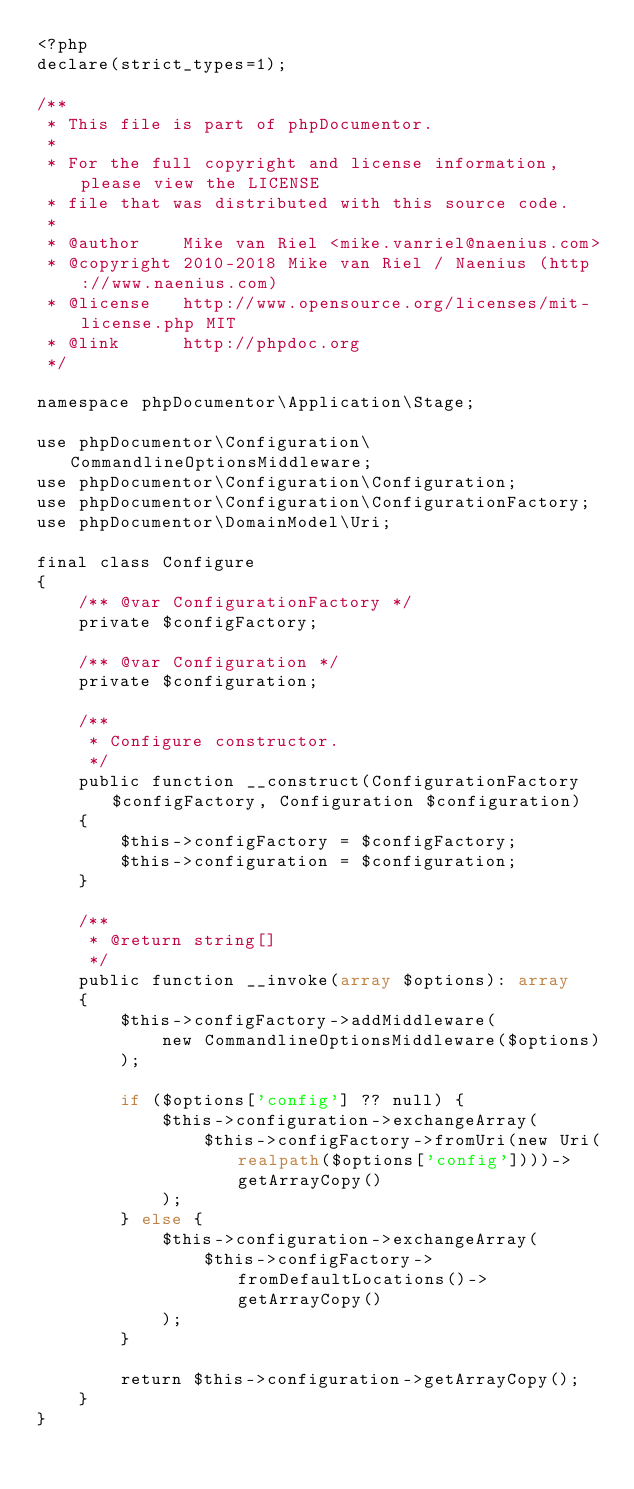<code> <loc_0><loc_0><loc_500><loc_500><_PHP_><?php
declare(strict_types=1);

/**
 * This file is part of phpDocumentor.
 *
 * For the full copyright and license information, please view the LICENSE
 * file that was distributed with this source code.
 *
 * @author    Mike van Riel <mike.vanriel@naenius.com>
 * @copyright 2010-2018 Mike van Riel / Naenius (http://www.naenius.com)
 * @license   http://www.opensource.org/licenses/mit-license.php MIT
 * @link      http://phpdoc.org
 */

namespace phpDocumentor\Application\Stage;

use phpDocumentor\Configuration\CommandlineOptionsMiddleware;
use phpDocumentor\Configuration\Configuration;
use phpDocumentor\Configuration\ConfigurationFactory;
use phpDocumentor\DomainModel\Uri;

final class Configure
{
    /** @var ConfigurationFactory */
    private $configFactory;

    /** @var Configuration */
    private $configuration;

    /**
     * Configure constructor.
     */
    public function __construct(ConfigurationFactory $configFactory, Configuration $configuration)
    {
        $this->configFactory = $configFactory;
        $this->configuration = $configuration;
    }

    /**
     * @return string[]
     */
    public function __invoke(array $options): array
    {
        $this->configFactory->addMiddleware(
            new CommandlineOptionsMiddleware($options)
        );

        if ($options['config'] ?? null) {
            $this->configuration->exchangeArray(
                $this->configFactory->fromUri(new Uri(realpath($options['config'])))->getArrayCopy()
            );
        } else {
            $this->configuration->exchangeArray(
                $this->configFactory->fromDefaultLocations()->getArrayCopy()
            );
        }

        return $this->configuration->getArrayCopy();
    }
}
</code> 